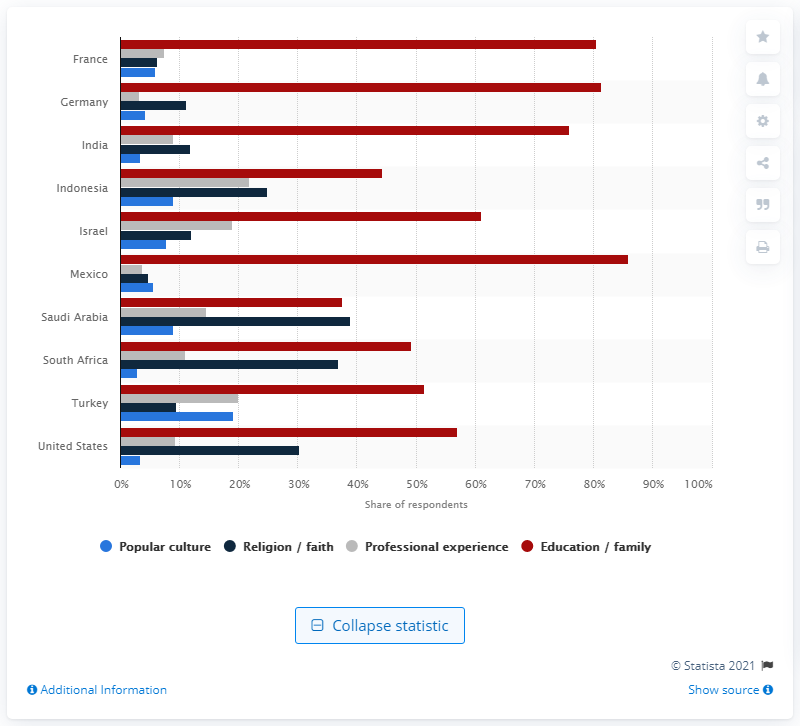Mention a couple of crucial points in this snapshot. According to a survey, 30.32% of Americans stated that they derive their personal values from their faith or religion. 